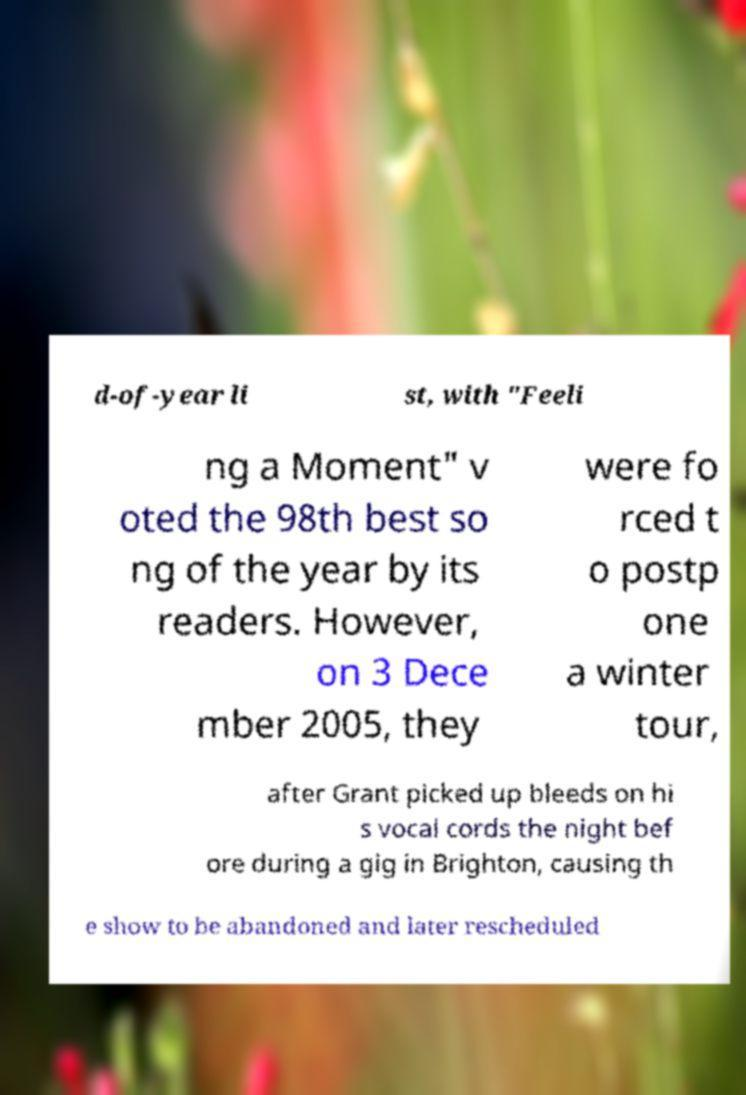Can you read and provide the text displayed in the image?This photo seems to have some interesting text. Can you extract and type it out for me? d-of-year li st, with "Feeli ng a Moment" v oted the 98th best so ng of the year by its readers. However, on 3 Dece mber 2005, they were fo rced t o postp one a winter tour, after Grant picked up bleeds on hi s vocal cords the night bef ore during a gig in Brighton, causing th e show to be abandoned and later rescheduled 